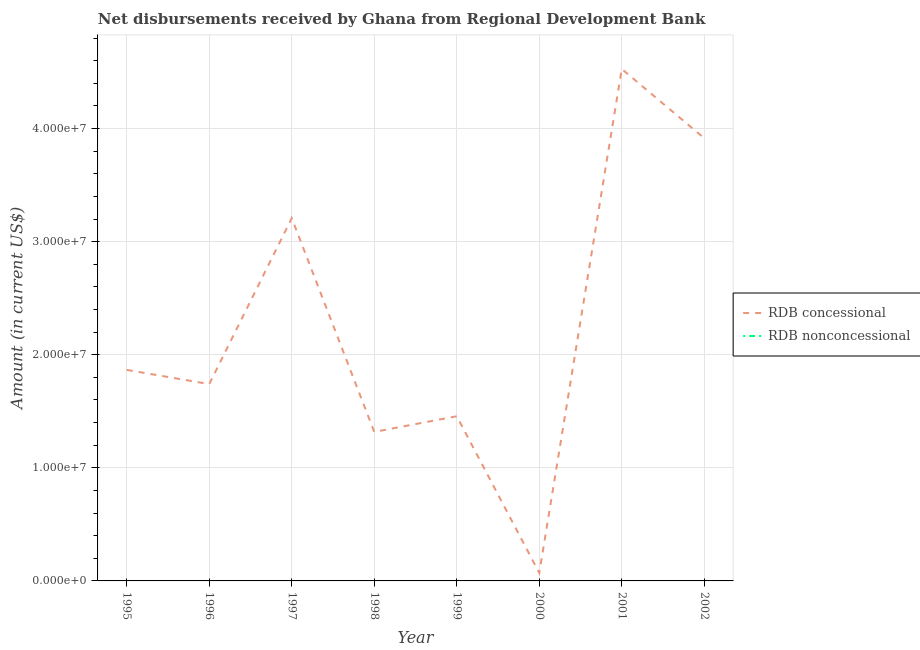How many different coloured lines are there?
Offer a terse response. 1. Does the line corresponding to net non concessional disbursements from rdb intersect with the line corresponding to net concessional disbursements from rdb?
Make the answer very short. No. Across all years, what is the maximum net concessional disbursements from rdb?
Give a very brief answer. 4.53e+07. Across all years, what is the minimum net non concessional disbursements from rdb?
Ensure brevity in your answer.  0. In which year was the net concessional disbursements from rdb maximum?
Give a very brief answer. 2001. What is the difference between the net concessional disbursements from rdb in 1998 and that in 1999?
Provide a succinct answer. -1.38e+06. What is the difference between the net non concessional disbursements from rdb in 1996 and the net concessional disbursements from rdb in 1997?
Make the answer very short. -3.21e+07. What is the average net concessional disbursements from rdb per year?
Offer a very short reply. 2.26e+07. In how many years, is the net concessional disbursements from rdb greater than 6000000 US$?
Give a very brief answer. 7. What is the ratio of the net concessional disbursements from rdb in 1996 to that in 2000?
Offer a very short reply. 24.65. What is the difference between the highest and the second highest net concessional disbursements from rdb?
Your answer should be compact. 6.12e+06. What is the difference between the highest and the lowest net concessional disbursements from rdb?
Keep it short and to the point. 4.46e+07. In how many years, is the net concessional disbursements from rdb greater than the average net concessional disbursements from rdb taken over all years?
Offer a very short reply. 3. Is the net concessional disbursements from rdb strictly less than the net non concessional disbursements from rdb over the years?
Your answer should be compact. No. Are the values on the major ticks of Y-axis written in scientific E-notation?
Provide a short and direct response. Yes. Does the graph contain grids?
Give a very brief answer. Yes. How many legend labels are there?
Make the answer very short. 2. How are the legend labels stacked?
Offer a very short reply. Vertical. What is the title of the graph?
Make the answer very short. Net disbursements received by Ghana from Regional Development Bank. What is the label or title of the X-axis?
Give a very brief answer. Year. What is the Amount (in current US$) of RDB concessional in 1995?
Your answer should be very brief. 1.87e+07. What is the Amount (in current US$) in RDB concessional in 1996?
Your response must be concise. 1.74e+07. What is the Amount (in current US$) of RDB nonconcessional in 1996?
Your answer should be very brief. 0. What is the Amount (in current US$) in RDB concessional in 1997?
Your answer should be compact. 3.21e+07. What is the Amount (in current US$) of RDB nonconcessional in 1997?
Your answer should be very brief. 0. What is the Amount (in current US$) of RDB concessional in 1998?
Your response must be concise. 1.32e+07. What is the Amount (in current US$) in RDB concessional in 1999?
Offer a terse response. 1.46e+07. What is the Amount (in current US$) of RDB concessional in 2000?
Provide a short and direct response. 7.06e+05. What is the Amount (in current US$) in RDB nonconcessional in 2000?
Your answer should be very brief. 0. What is the Amount (in current US$) in RDB concessional in 2001?
Offer a terse response. 4.53e+07. What is the Amount (in current US$) of RDB nonconcessional in 2001?
Ensure brevity in your answer.  0. What is the Amount (in current US$) in RDB concessional in 2002?
Make the answer very short. 3.91e+07. What is the Amount (in current US$) of RDB nonconcessional in 2002?
Offer a very short reply. 0. Across all years, what is the maximum Amount (in current US$) in RDB concessional?
Ensure brevity in your answer.  4.53e+07. Across all years, what is the minimum Amount (in current US$) in RDB concessional?
Your answer should be compact. 7.06e+05. What is the total Amount (in current US$) in RDB concessional in the graph?
Provide a succinct answer. 1.81e+08. What is the total Amount (in current US$) of RDB nonconcessional in the graph?
Your answer should be compact. 0. What is the difference between the Amount (in current US$) of RDB concessional in 1995 and that in 1996?
Give a very brief answer. 1.25e+06. What is the difference between the Amount (in current US$) in RDB concessional in 1995 and that in 1997?
Offer a terse response. -1.34e+07. What is the difference between the Amount (in current US$) of RDB concessional in 1995 and that in 1998?
Your answer should be very brief. 5.48e+06. What is the difference between the Amount (in current US$) in RDB concessional in 1995 and that in 1999?
Ensure brevity in your answer.  4.10e+06. What is the difference between the Amount (in current US$) of RDB concessional in 1995 and that in 2000?
Your answer should be compact. 1.80e+07. What is the difference between the Amount (in current US$) of RDB concessional in 1995 and that in 2001?
Provide a short and direct response. -2.66e+07. What is the difference between the Amount (in current US$) in RDB concessional in 1995 and that in 2002?
Offer a terse response. -2.05e+07. What is the difference between the Amount (in current US$) in RDB concessional in 1996 and that in 1997?
Your answer should be compact. -1.47e+07. What is the difference between the Amount (in current US$) of RDB concessional in 1996 and that in 1998?
Offer a very short reply. 4.23e+06. What is the difference between the Amount (in current US$) of RDB concessional in 1996 and that in 1999?
Make the answer very short. 2.84e+06. What is the difference between the Amount (in current US$) in RDB concessional in 1996 and that in 2000?
Keep it short and to the point. 1.67e+07. What is the difference between the Amount (in current US$) in RDB concessional in 1996 and that in 2001?
Offer a very short reply. -2.79e+07. What is the difference between the Amount (in current US$) of RDB concessional in 1996 and that in 2002?
Provide a succinct answer. -2.17e+07. What is the difference between the Amount (in current US$) of RDB concessional in 1997 and that in 1998?
Give a very brief answer. 1.89e+07. What is the difference between the Amount (in current US$) in RDB concessional in 1997 and that in 1999?
Ensure brevity in your answer.  1.75e+07. What is the difference between the Amount (in current US$) in RDB concessional in 1997 and that in 2000?
Your response must be concise. 3.14e+07. What is the difference between the Amount (in current US$) in RDB concessional in 1997 and that in 2001?
Your response must be concise. -1.32e+07. What is the difference between the Amount (in current US$) in RDB concessional in 1997 and that in 2002?
Your answer should be compact. -7.07e+06. What is the difference between the Amount (in current US$) in RDB concessional in 1998 and that in 1999?
Provide a succinct answer. -1.38e+06. What is the difference between the Amount (in current US$) in RDB concessional in 1998 and that in 2000?
Offer a very short reply. 1.25e+07. What is the difference between the Amount (in current US$) in RDB concessional in 1998 and that in 2001?
Offer a terse response. -3.21e+07. What is the difference between the Amount (in current US$) in RDB concessional in 1998 and that in 2002?
Provide a succinct answer. -2.60e+07. What is the difference between the Amount (in current US$) of RDB concessional in 1999 and that in 2000?
Keep it short and to the point. 1.39e+07. What is the difference between the Amount (in current US$) in RDB concessional in 1999 and that in 2001?
Provide a succinct answer. -3.07e+07. What is the difference between the Amount (in current US$) in RDB concessional in 1999 and that in 2002?
Make the answer very short. -2.46e+07. What is the difference between the Amount (in current US$) in RDB concessional in 2000 and that in 2001?
Offer a terse response. -4.46e+07. What is the difference between the Amount (in current US$) in RDB concessional in 2000 and that in 2002?
Offer a very short reply. -3.84e+07. What is the difference between the Amount (in current US$) of RDB concessional in 2001 and that in 2002?
Provide a succinct answer. 6.12e+06. What is the average Amount (in current US$) of RDB concessional per year?
Make the answer very short. 2.26e+07. What is the ratio of the Amount (in current US$) in RDB concessional in 1995 to that in 1996?
Your answer should be compact. 1.07. What is the ratio of the Amount (in current US$) in RDB concessional in 1995 to that in 1997?
Make the answer very short. 0.58. What is the ratio of the Amount (in current US$) of RDB concessional in 1995 to that in 1998?
Offer a terse response. 1.42. What is the ratio of the Amount (in current US$) of RDB concessional in 1995 to that in 1999?
Ensure brevity in your answer.  1.28. What is the ratio of the Amount (in current US$) in RDB concessional in 1995 to that in 2000?
Your answer should be very brief. 26.43. What is the ratio of the Amount (in current US$) in RDB concessional in 1995 to that in 2001?
Offer a terse response. 0.41. What is the ratio of the Amount (in current US$) in RDB concessional in 1995 to that in 2002?
Provide a short and direct response. 0.48. What is the ratio of the Amount (in current US$) of RDB concessional in 1996 to that in 1997?
Your response must be concise. 0.54. What is the ratio of the Amount (in current US$) in RDB concessional in 1996 to that in 1998?
Your response must be concise. 1.32. What is the ratio of the Amount (in current US$) in RDB concessional in 1996 to that in 1999?
Make the answer very short. 1.2. What is the ratio of the Amount (in current US$) of RDB concessional in 1996 to that in 2000?
Keep it short and to the point. 24.65. What is the ratio of the Amount (in current US$) in RDB concessional in 1996 to that in 2001?
Your answer should be compact. 0.38. What is the ratio of the Amount (in current US$) in RDB concessional in 1996 to that in 2002?
Provide a short and direct response. 0.44. What is the ratio of the Amount (in current US$) of RDB concessional in 1997 to that in 1998?
Make the answer very short. 2.43. What is the ratio of the Amount (in current US$) in RDB concessional in 1997 to that in 1999?
Give a very brief answer. 2.2. What is the ratio of the Amount (in current US$) in RDB concessional in 1997 to that in 2000?
Your answer should be compact. 45.43. What is the ratio of the Amount (in current US$) in RDB concessional in 1997 to that in 2001?
Ensure brevity in your answer.  0.71. What is the ratio of the Amount (in current US$) in RDB concessional in 1997 to that in 2002?
Your answer should be compact. 0.82. What is the ratio of the Amount (in current US$) of RDB concessional in 1998 to that in 1999?
Give a very brief answer. 0.91. What is the ratio of the Amount (in current US$) in RDB concessional in 1998 to that in 2000?
Your answer should be very brief. 18.66. What is the ratio of the Amount (in current US$) in RDB concessional in 1998 to that in 2001?
Your response must be concise. 0.29. What is the ratio of the Amount (in current US$) in RDB concessional in 1998 to that in 2002?
Your answer should be very brief. 0.34. What is the ratio of the Amount (in current US$) in RDB concessional in 1999 to that in 2000?
Offer a very short reply. 20.62. What is the ratio of the Amount (in current US$) in RDB concessional in 1999 to that in 2001?
Give a very brief answer. 0.32. What is the ratio of the Amount (in current US$) of RDB concessional in 1999 to that in 2002?
Provide a succinct answer. 0.37. What is the ratio of the Amount (in current US$) in RDB concessional in 2000 to that in 2001?
Your response must be concise. 0.02. What is the ratio of the Amount (in current US$) of RDB concessional in 2000 to that in 2002?
Your response must be concise. 0.02. What is the ratio of the Amount (in current US$) of RDB concessional in 2001 to that in 2002?
Ensure brevity in your answer.  1.16. What is the difference between the highest and the second highest Amount (in current US$) of RDB concessional?
Provide a short and direct response. 6.12e+06. What is the difference between the highest and the lowest Amount (in current US$) in RDB concessional?
Your answer should be very brief. 4.46e+07. 